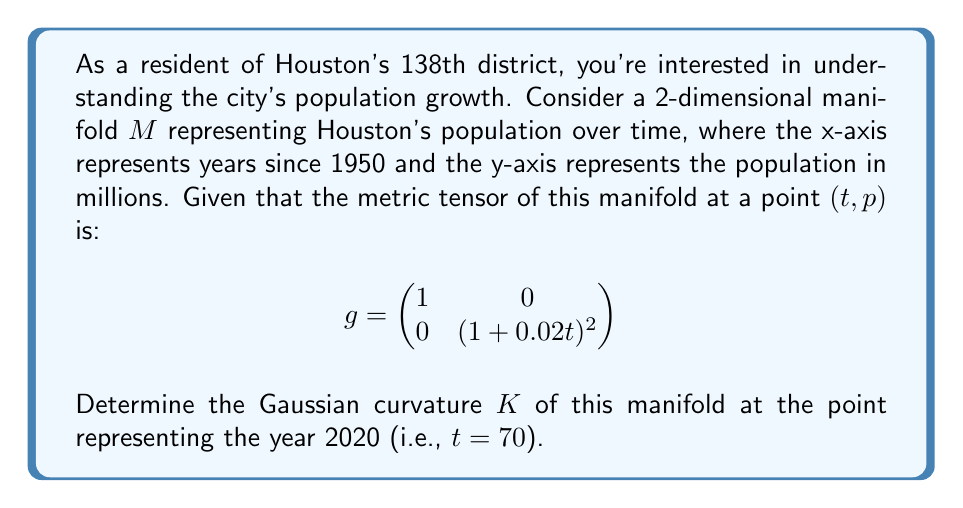Could you help me with this problem? To find the Gaussian curvature of the manifold, we need to follow these steps:

1) The Gaussian curvature $K$ is given by:

   $$K = \frac{R_{1212}}{det(g)}$$

   where $R_{1212}$ is the only non-zero component of the Riemann curvature tensor for a 2D manifold.

2) To calculate $R_{1212}$, we use the formula:

   $$R_{1212} = \frac{1}{2}(\partial_1\partial_1 g_{22} - \partial_1\partial_2 g_{12} - \partial_2\partial_1 g_{12} + \partial_2\partial_2 g_{11})$$

3) In our case:
   $g_{11} = 1$
   $g_{12} = g_{21} = 0$
   $g_{22} = (1 + 0.02t)^2$

4) Calculating the derivatives:
   $\partial_1\partial_1 g_{22} = 2(0.02)^2 = 0.0008$
   $\partial_1\partial_2 g_{12} = \partial_2\partial_1 g_{12} = 0$
   $\partial_2\partial_2 g_{11} = 0$

5) Therefore:
   $$R_{1212} = \frac{1}{2}(0.0008) = 0.0004$$

6) The determinant of $g$ is:
   $$det(g) = 1 \cdot (1 + 0.02t)^2 = (1 + 0.02t)^2$$

7) Thus, the Gaussian curvature is:
   $$K = \frac{0.0004}{(1 + 0.02t)^2}$$

8) At $t = 70$ (year 2020):
   $$K = \frac{0.0004}{(1 + 0.02 \cdot 70)^2} = \frac{0.0004}{2.4^2} \approx 0.0000694$$
Answer: The Gaussian curvature of the manifold representing Houston's population growth at the point corresponding to the year 2020 is approximately $6.94 \times 10^{-5}$. 